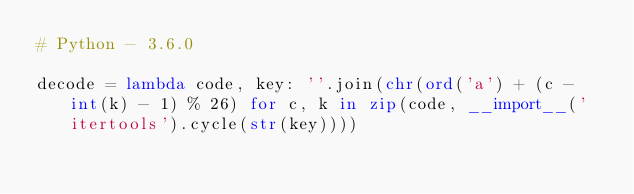Convert code to text. <code><loc_0><loc_0><loc_500><loc_500><_Python_># Python - 3.6.0

decode = lambda code, key: ''.join(chr(ord('a') + (c - int(k) - 1) % 26) for c, k in zip(code, __import__('itertools').cycle(str(key))))
</code> 